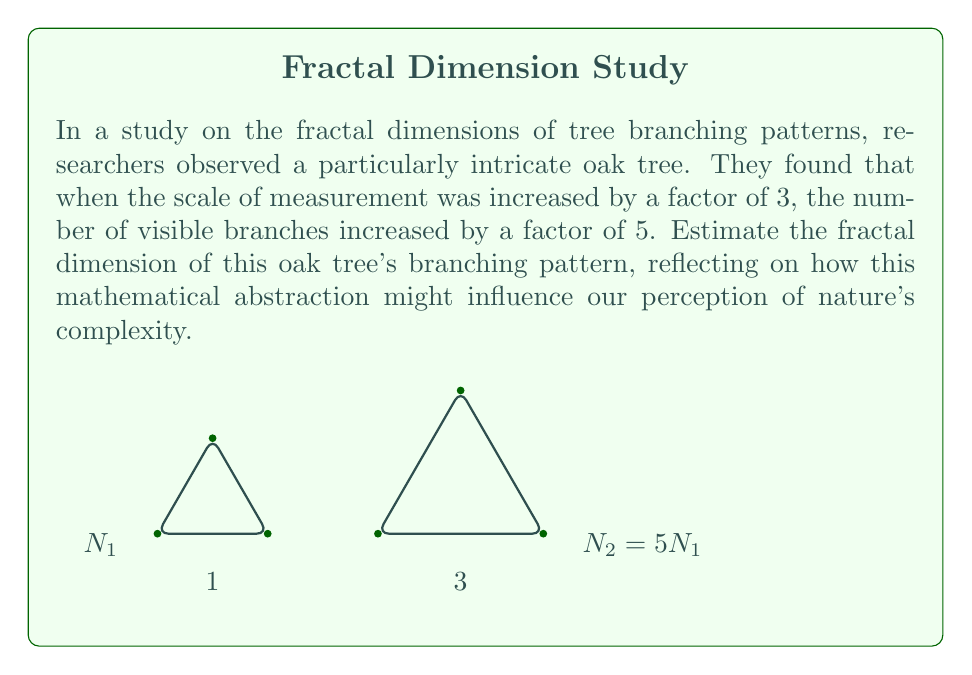Can you solve this math problem? To estimate the fractal dimension of the oak tree's branching pattern, we'll use the box-counting method, which is fundamental in fractal geometry. The fractal dimension $D$ is given by the formula:

$$D = \frac{\log(N)}{\log(1/r)}$$

Where:
$N$ is the number of self-similar pieces
$r$ is the scale factor

Step 1: Identify the given information
- Scale factor: $r = 1/3$ (scale increased by a factor of 3)
- Number of visible branches increased by a factor of 5

Step 2: Set up the equation
$$D = \frac{\log(5)}{\log(3)}$$

Step 3: Calculate the fractal dimension
Using a calculator or logarithm tables:

$$D \approx \frac{0.6989}{0.4771} \approx 1.4648$$

This value, being between 1 and 2, suggests a complex branching pattern that fills more space than a simple line (dimension 1) but less than a plane (dimension 2).

Philosophical reflection: This mathematical abstraction allows us to quantify the complexity of natural forms. However, as philosophers considering our connection to nature, we might ponder whether reducing nature's intricate beauty to a single number truly captures its essence, or if it potentially distances us from a more holistic appreciation of the natural world.
Answer: $D \approx 1.4648$ 